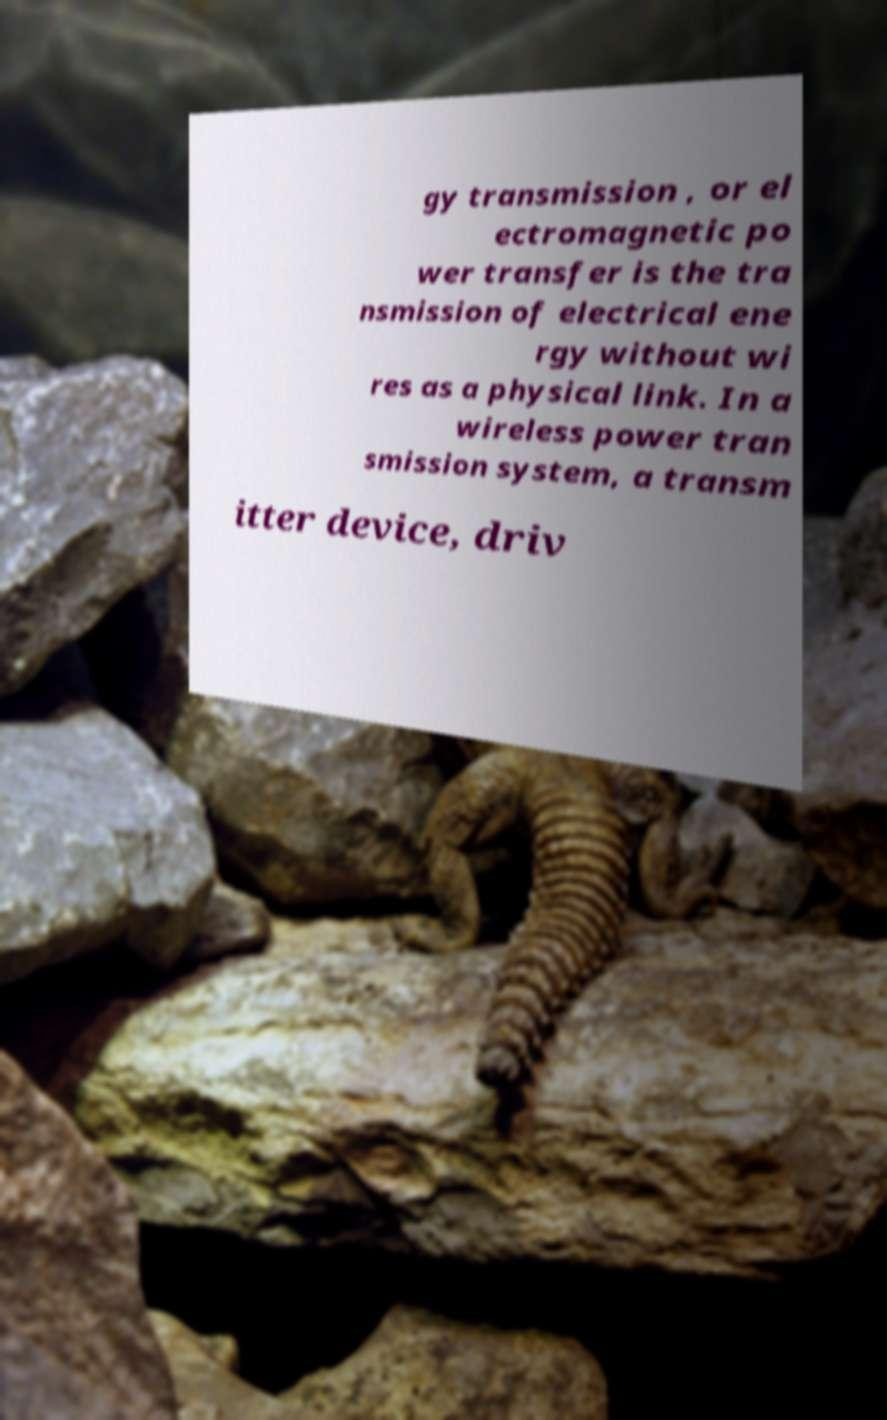Can you accurately transcribe the text from the provided image for me? gy transmission , or el ectromagnetic po wer transfer is the tra nsmission of electrical ene rgy without wi res as a physical link. In a wireless power tran smission system, a transm itter device, driv 